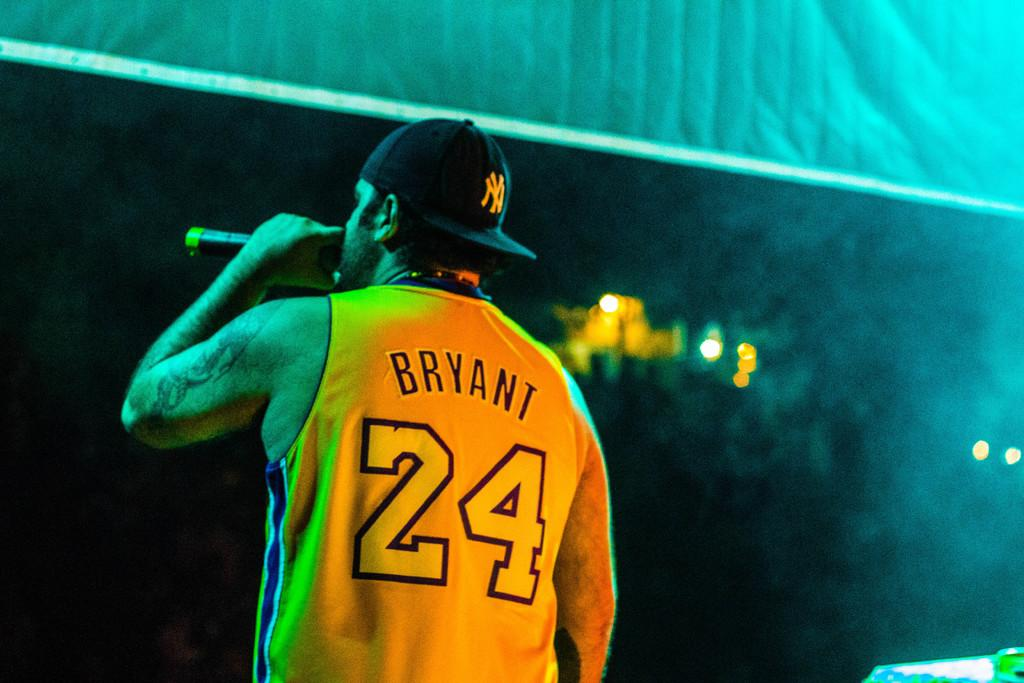<image>
Give a short and clear explanation of the subsequent image. A man wearing a jersey with the number 24 on the back is holding a microphone. 